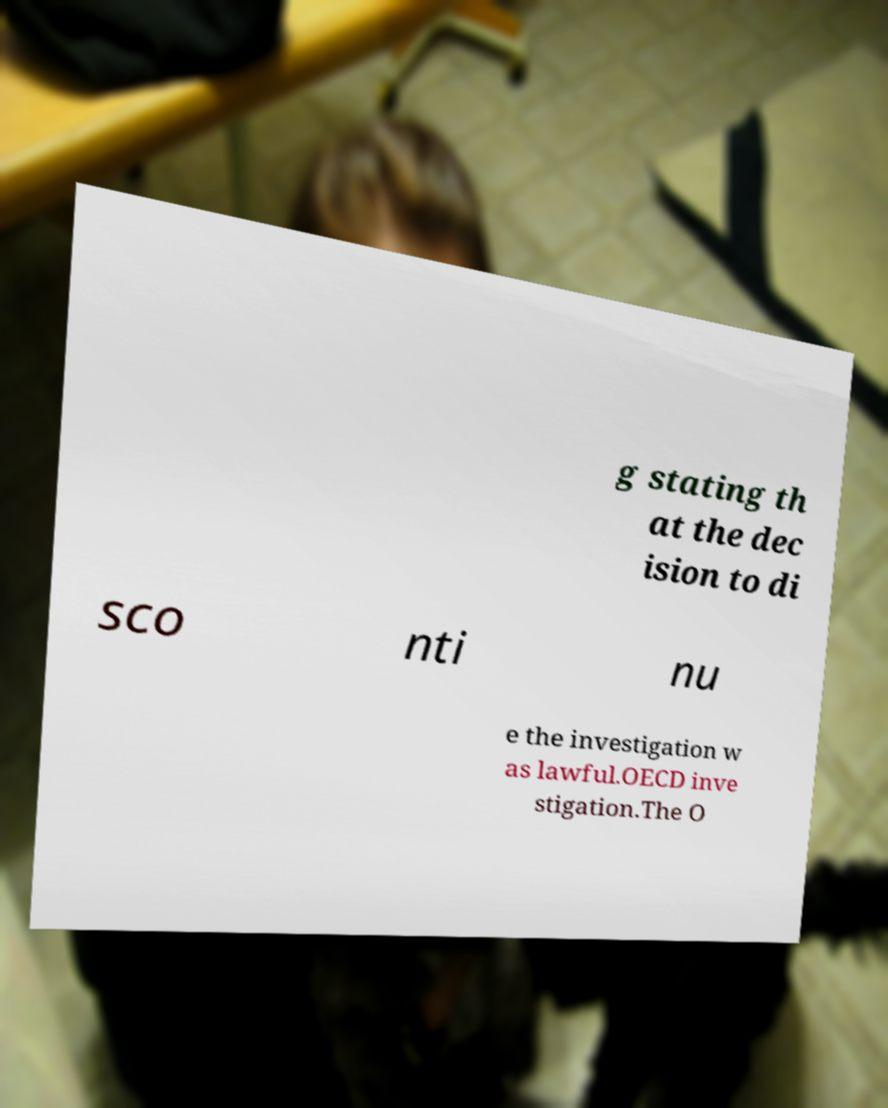For documentation purposes, I need the text within this image transcribed. Could you provide that? g stating th at the dec ision to di sco nti nu e the investigation w as lawful.OECD inve stigation.The O 